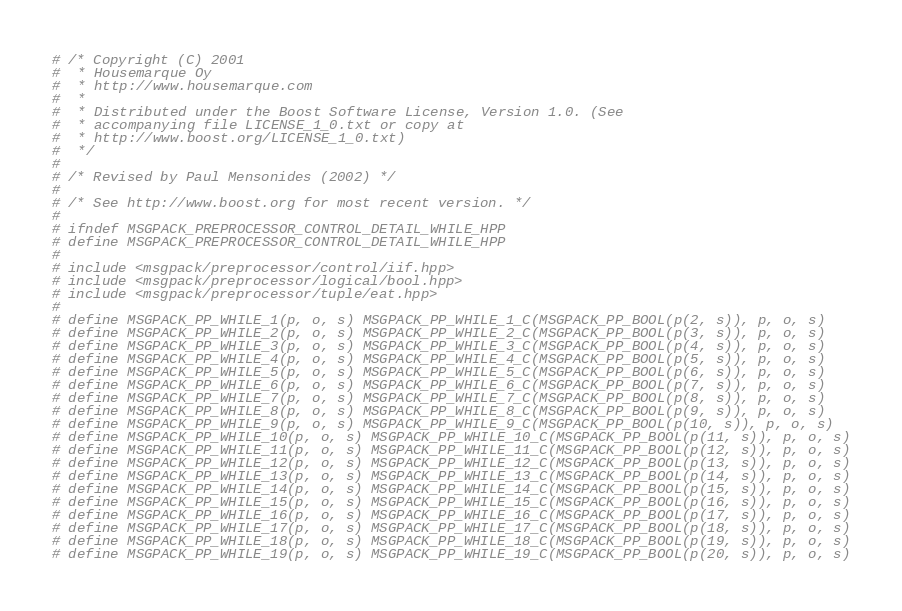<code> <loc_0><loc_0><loc_500><loc_500><_C++_># /* Copyright (C) 2001
#  * Housemarque Oy
#  * http://www.housemarque.com
#  *
#  * Distributed under the Boost Software License, Version 1.0. (See
#  * accompanying file LICENSE_1_0.txt or copy at
#  * http://www.boost.org/LICENSE_1_0.txt)
#  */
#
# /* Revised by Paul Mensonides (2002) */
#
# /* See http://www.boost.org for most recent version. */
#
# ifndef MSGPACK_PREPROCESSOR_CONTROL_DETAIL_WHILE_HPP
# define MSGPACK_PREPROCESSOR_CONTROL_DETAIL_WHILE_HPP
#
# include <msgpack/preprocessor/control/iif.hpp>
# include <msgpack/preprocessor/logical/bool.hpp>
# include <msgpack/preprocessor/tuple/eat.hpp>
#
# define MSGPACK_PP_WHILE_1(p, o, s) MSGPACK_PP_WHILE_1_C(MSGPACK_PP_BOOL(p(2, s)), p, o, s)
# define MSGPACK_PP_WHILE_2(p, o, s) MSGPACK_PP_WHILE_2_C(MSGPACK_PP_BOOL(p(3, s)), p, o, s)
# define MSGPACK_PP_WHILE_3(p, o, s) MSGPACK_PP_WHILE_3_C(MSGPACK_PP_BOOL(p(4, s)), p, o, s)
# define MSGPACK_PP_WHILE_4(p, o, s) MSGPACK_PP_WHILE_4_C(MSGPACK_PP_BOOL(p(5, s)), p, o, s)
# define MSGPACK_PP_WHILE_5(p, o, s) MSGPACK_PP_WHILE_5_C(MSGPACK_PP_BOOL(p(6, s)), p, o, s)
# define MSGPACK_PP_WHILE_6(p, o, s) MSGPACK_PP_WHILE_6_C(MSGPACK_PP_BOOL(p(7, s)), p, o, s)
# define MSGPACK_PP_WHILE_7(p, o, s) MSGPACK_PP_WHILE_7_C(MSGPACK_PP_BOOL(p(8, s)), p, o, s)
# define MSGPACK_PP_WHILE_8(p, o, s) MSGPACK_PP_WHILE_8_C(MSGPACK_PP_BOOL(p(9, s)), p, o, s)
# define MSGPACK_PP_WHILE_9(p, o, s) MSGPACK_PP_WHILE_9_C(MSGPACK_PP_BOOL(p(10, s)), p, o, s)
# define MSGPACK_PP_WHILE_10(p, o, s) MSGPACK_PP_WHILE_10_C(MSGPACK_PP_BOOL(p(11, s)), p, o, s)
# define MSGPACK_PP_WHILE_11(p, o, s) MSGPACK_PP_WHILE_11_C(MSGPACK_PP_BOOL(p(12, s)), p, o, s)
# define MSGPACK_PP_WHILE_12(p, o, s) MSGPACK_PP_WHILE_12_C(MSGPACK_PP_BOOL(p(13, s)), p, o, s)
# define MSGPACK_PP_WHILE_13(p, o, s) MSGPACK_PP_WHILE_13_C(MSGPACK_PP_BOOL(p(14, s)), p, o, s)
# define MSGPACK_PP_WHILE_14(p, o, s) MSGPACK_PP_WHILE_14_C(MSGPACK_PP_BOOL(p(15, s)), p, o, s)
# define MSGPACK_PP_WHILE_15(p, o, s) MSGPACK_PP_WHILE_15_C(MSGPACK_PP_BOOL(p(16, s)), p, o, s)
# define MSGPACK_PP_WHILE_16(p, o, s) MSGPACK_PP_WHILE_16_C(MSGPACK_PP_BOOL(p(17, s)), p, o, s)
# define MSGPACK_PP_WHILE_17(p, o, s) MSGPACK_PP_WHILE_17_C(MSGPACK_PP_BOOL(p(18, s)), p, o, s)
# define MSGPACK_PP_WHILE_18(p, o, s) MSGPACK_PP_WHILE_18_C(MSGPACK_PP_BOOL(p(19, s)), p, o, s)
# define MSGPACK_PP_WHILE_19(p, o, s) MSGPACK_PP_WHILE_19_C(MSGPACK_PP_BOOL(p(20, s)), p, o, s)</code> 